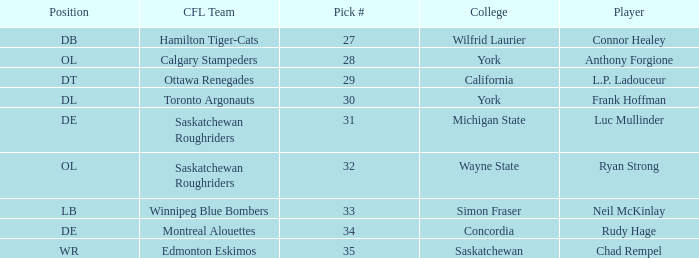What is the Pick # for Ryan Strong? 32.0. 